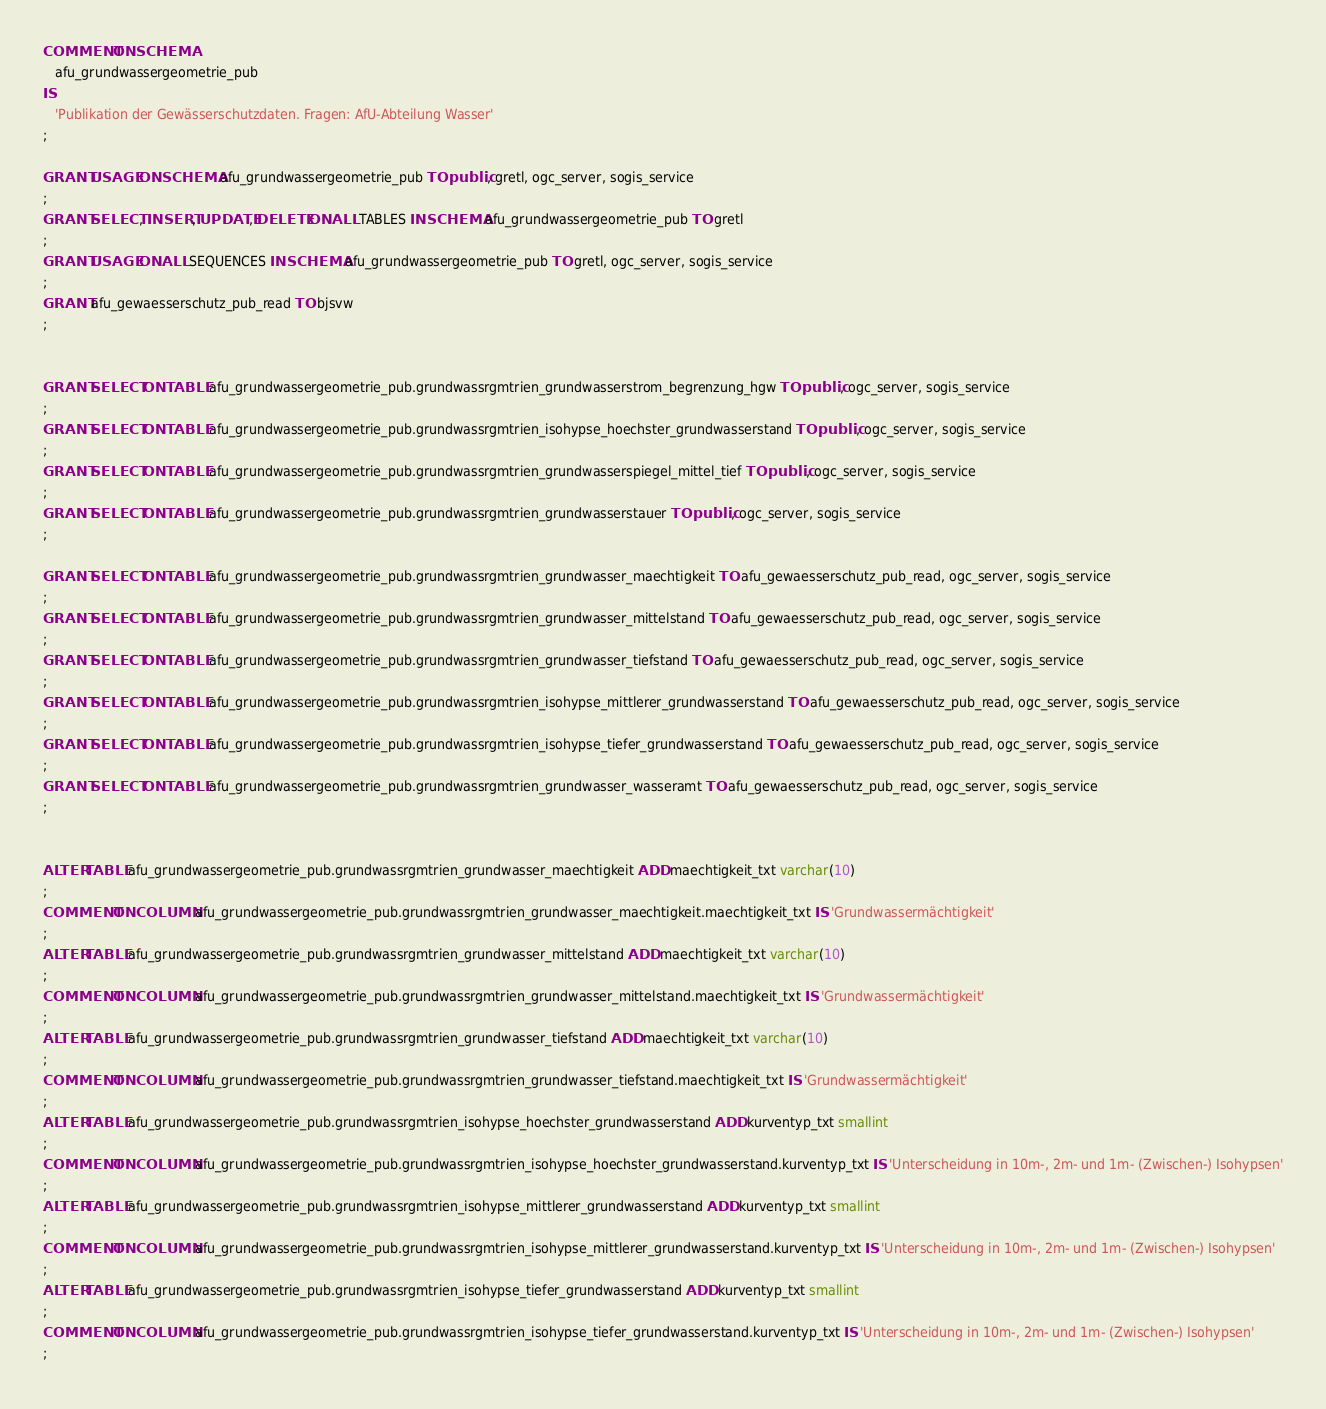<code> <loc_0><loc_0><loc_500><loc_500><_SQL_>COMMENT ON SCHEMA 
   afu_grundwassergeometrie_pub
IS 
   'Publikation der Gewässerschutzdaten. Fragen: AfU-Abteilung Wasser'
;

GRANT USAGE ON SCHEMA afu_grundwassergeometrie_pub TO public, gretl, ogc_server, sogis_service
;
GRANT SELECT, INSERT, UPDATE, DELETE ON ALL TABLES IN SCHEMA afu_grundwassergeometrie_pub TO gretl
;
GRANT USAGE ON ALL SEQUENCES IN SCHEMA afu_grundwassergeometrie_pub TO gretl, ogc_server, sogis_service
;
GRANT afu_gewaesserschutz_pub_read TO bjsvw
;


GRANT SELECT ON TABLE afu_grundwassergeometrie_pub.grundwassrgmtrien_grundwasserstrom_begrenzung_hgw TO public, ogc_server, sogis_service
;
GRANT SELECT ON TABLE afu_grundwassergeometrie_pub.grundwassrgmtrien_isohypse_hoechster_grundwasserstand TO public, ogc_server, sogis_service
;
GRANT SELECT ON TABLE afu_grundwassergeometrie_pub.grundwassrgmtrien_grundwasserspiegel_mittel_tief TO public, ogc_server, sogis_service
;
GRANT SELECT ON TABLE afu_grundwassergeometrie_pub.grundwassrgmtrien_grundwasserstauer TO public, ogc_server, sogis_service
;

GRANT SELECT ON TABLE afu_grundwassergeometrie_pub.grundwassrgmtrien_grundwasser_maechtigkeit TO afu_gewaesserschutz_pub_read, ogc_server, sogis_service
;
GRANT SELECT ON TABLE afu_grundwassergeometrie_pub.grundwassrgmtrien_grundwasser_mittelstand TO afu_gewaesserschutz_pub_read, ogc_server, sogis_service
;
GRANT SELECT ON TABLE afu_grundwassergeometrie_pub.grundwassrgmtrien_grundwasser_tiefstand TO afu_gewaesserschutz_pub_read, ogc_server, sogis_service
;
GRANT SELECT ON TABLE afu_grundwassergeometrie_pub.grundwassrgmtrien_isohypse_mittlerer_grundwasserstand TO afu_gewaesserschutz_pub_read, ogc_server, sogis_service
;
GRANT SELECT ON TABLE afu_grundwassergeometrie_pub.grundwassrgmtrien_isohypse_tiefer_grundwasserstand TO afu_gewaesserschutz_pub_read, ogc_server, sogis_service
;
GRANT SELECT ON TABLE afu_grundwassergeometrie_pub.grundwassrgmtrien_grundwasser_wasseramt TO afu_gewaesserschutz_pub_read, ogc_server, sogis_service
;


ALTER TABLE afu_grundwassergeometrie_pub.grundwassrgmtrien_grundwasser_maechtigkeit ADD maechtigkeit_txt varchar(10)
;
COMMENT ON COLUMN afu_grundwassergeometrie_pub.grundwassrgmtrien_grundwasser_maechtigkeit.maechtigkeit_txt IS 'Grundwassermächtigkeit'
;
ALTER TABLE afu_grundwassergeometrie_pub.grundwassrgmtrien_grundwasser_mittelstand ADD maechtigkeit_txt varchar(10)
;
COMMENT ON COLUMN afu_grundwassergeometrie_pub.grundwassrgmtrien_grundwasser_mittelstand.maechtigkeit_txt IS 'Grundwassermächtigkeit'
;
ALTER TABLE afu_grundwassergeometrie_pub.grundwassrgmtrien_grundwasser_tiefstand ADD maechtigkeit_txt varchar(10)
;
COMMENT ON COLUMN afu_grundwassergeometrie_pub.grundwassrgmtrien_grundwasser_tiefstand.maechtigkeit_txt IS 'Grundwassermächtigkeit'
;
ALTER TABLE afu_grundwassergeometrie_pub.grundwassrgmtrien_isohypse_hoechster_grundwasserstand ADD kurventyp_txt smallint
;
COMMENT ON COLUMN afu_grundwassergeometrie_pub.grundwassrgmtrien_isohypse_hoechster_grundwasserstand.kurventyp_txt IS 'Unterscheidung in 10m-, 2m- und 1m- (Zwischen-) Isohypsen'
;
ALTER TABLE afu_grundwassergeometrie_pub.grundwassrgmtrien_isohypse_mittlerer_grundwasserstand ADD kurventyp_txt smallint
;
COMMENT ON COLUMN afu_grundwassergeometrie_pub.grundwassrgmtrien_isohypse_mittlerer_grundwasserstand.kurventyp_txt IS 'Unterscheidung in 10m-, 2m- und 1m- (Zwischen-) Isohypsen'
;
ALTER TABLE afu_grundwassergeometrie_pub.grundwassrgmtrien_isohypse_tiefer_grundwasserstand ADD kurventyp_txt smallint
;
COMMENT ON COLUMN afu_grundwassergeometrie_pub.grundwassrgmtrien_isohypse_tiefer_grundwasserstand.kurventyp_txt IS 'Unterscheidung in 10m-, 2m- und 1m- (Zwischen-) Isohypsen'
;
</code> 